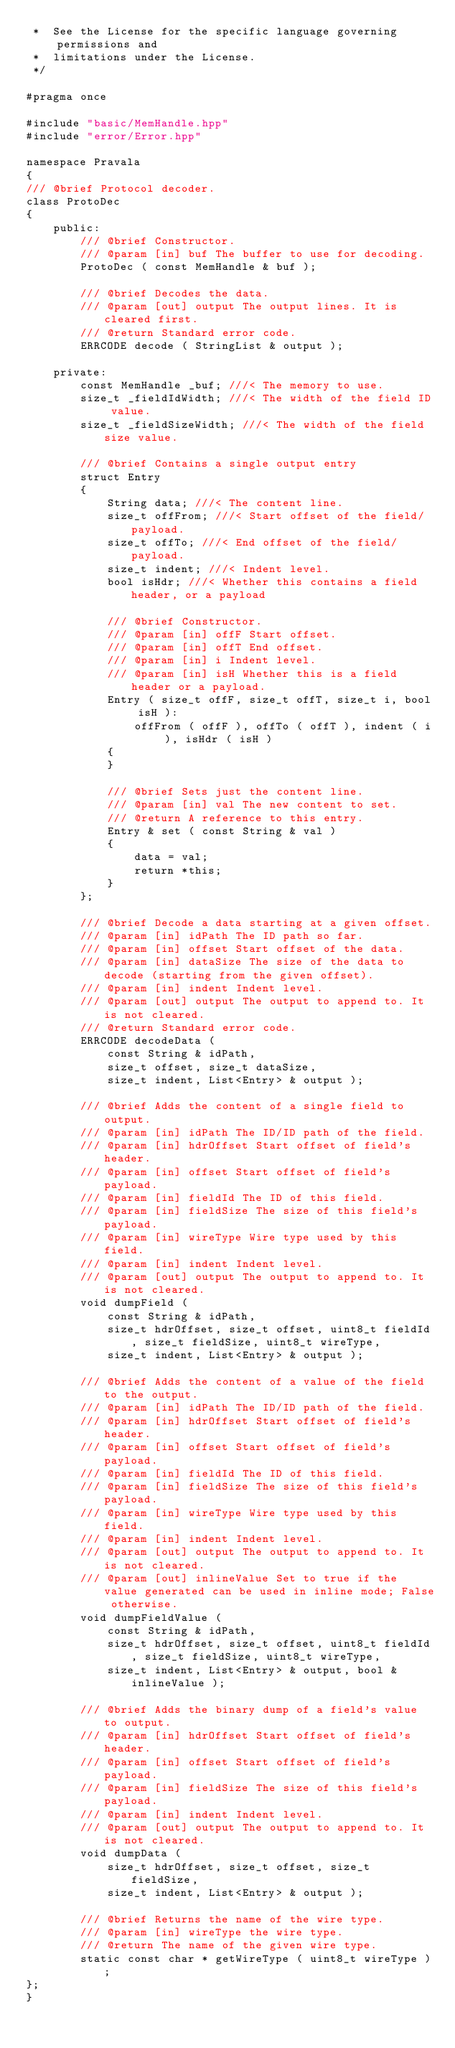Convert code to text. <code><loc_0><loc_0><loc_500><loc_500><_C++_> *  See the License for the specific language governing permissions and
 *  limitations under the License.
 */

#pragma once

#include "basic/MemHandle.hpp"
#include "error/Error.hpp"

namespace Pravala
{
/// @brief Protocol decoder.
class ProtoDec
{
    public:
        /// @brief Constructor.
        /// @param [in] buf The buffer to use for decoding.
        ProtoDec ( const MemHandle & buf );

        /// @brief Decodes the data.
        /// @param [out] output The output lines. It is cleared first.
        /// @return Standard error code.
        ERRCODE decode ( StringList & output );

    private:
        const MemHandle _buf; ///< The memory to use.
        size_t _fieldIdWidth; ///< The width of the field ID value.
        size_t _fieldSizeWidth; ///< The width of the field size value.

        /// @brief Contains a single output entry
        struct Entry
        {
            String data; ///< The content line.
            size_t offFrom; ///< Start offset of the field/payload.
            size_t offTo; ///< End offset of the field/payload.
            size_t indent; ///< Indent level.
            bool isHdr; ///< Whether this contains a field header, or a payload

            /// @brief Constructor.
            /// @param [in] offF Start offset.
            /// @param [in] offT End offset.
            /// @param [in] i Indent level.
            /// @param [in] isH Whether this is a field header or a payload.
            Entry ( size_t offF, size_t offT, size_t i, bool isH ):
                offFrom ( offF ), offTo ( offT ), indent ( i ), isHdr ( isH )
            {
            }

            /// @brief Sets just the content line.
            /// @param [in] val The new content to set.
            /// @return A reference to this entry.
            Entry & set ( const String & val )
            {
                data = val;
                return *this;
            }
        };

        /// @brief Decode a data starting at a given offset.
        /// @param [in] idPath The ID path so far.
        /// @param [in] offset Start offset of the data.
        /// @param [in] dataSize The size of the data to decode (starting from the given offset).
        /// @param [in] indent Indent level.
        /// @param [out] output The output to append to. It is not cleared.
        /// @return Standard error code.
        ERRCODE decodeData (
            const String & idPath,
            size_t offset, size_t dataSize,
            size_t indent, List<Entry> & output );

        /// @brief Adds the content of a single field to output.
        /// @param [in] idPath The ID/ID path of the field.
        /// @param [in] hdrOffset Start offset of field's header.
        /// @param [in] offset Start offset of field's payload.
        /// @param [in] fieldId The ID of this field.
        /// @param [in] fieldSize The size of this field's payload.
        /// @param [in] wireType Wire type used by this field.
        /// @param [in] indent Indent level.
        /// @param [out] output The output to append to. It is not cleared.
        void dumpField (
            const String & idPath,
            size_t hdrOffset, size_t offset, uint8_t fieldId, size_t fieldSize, uint8_t wireType,
            size_t indent, List<Entry> & output );

        /// @brief Adds the content of a value of the field to the output.
        /// @param [in] idPath The ID/ID path of the field.
        /// @param [in] hdrOffset Start offset of field's header.
        /// @param [in] offset Start offset of field's payload.
        /// @param [in] fieldId The ID of this field.
        /// @param [in] fieldSize The size of this field's payload.
        /// @param [in] wireType Wire type used by this field.
        /// @param [in] indent Indent level.
        /// @param [out] output The output to append to. It is not cleared.
        /// @param [out] inlineValue Set to true if the value generated can be used in inline mode; False otherwise.
        void dumpFieldValue (
            const String & idPath,
            size_t hdrOffset, size_t offset, uint8_t fieldId, size_t fieldSize, uint8_t wireType,
            size_t indent, List<Entry> & output, bool & inlineValue );

        /// @brief Adds the binary dump of a field's value to output.
        /// @param [in] hdrOffset Start offset of field's header.
        /// @param [in] offset Start offset of field's payload.
        /// @param [in] fieldSize The size of this field's payload.
        /// @param [in] indent Indent level.
        /// @param [out] output The output to append to. It is not cleared.
        void dumpData (
            size_t hdrOffset, size_t offset, size_t fieldSize,
            size_t indent, List<Entry> & output );

        /// @brief Returns the name of the wire type.
        /// @param [in] wireType the wire type.
        /// @return The name of the given wire type.
        static const char * getWireType ( uint8_t wireType );
};
}
</code> 